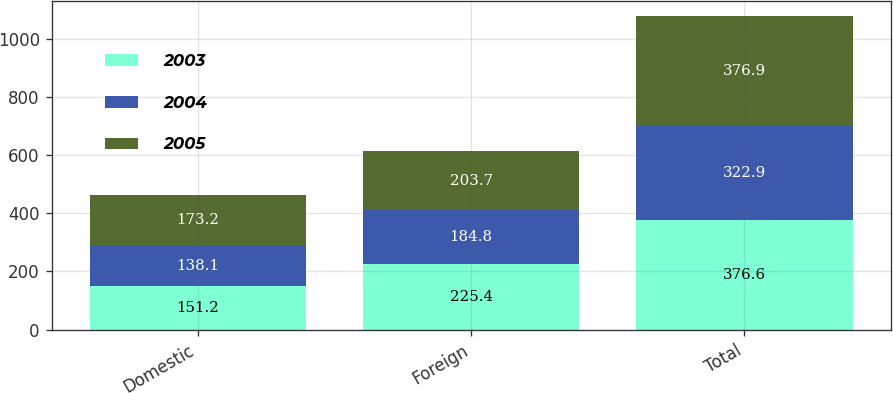<chart> <loc_0><loc_0><loc_500><loc_500><stacked_bar_chart><ecel><fcel>Domestic<fcel>Foreign<fcel>Total<nl><fcel>2003<fcel>151.2<fcel>225.4<fcel>376.6<nl><fcel>2004<fcel>138.1<fcel>184.8<fcel>322.9<nl><fcel>2005<fcel>173.2<fcel>203.7<fcel>376.9<nl></chart> 